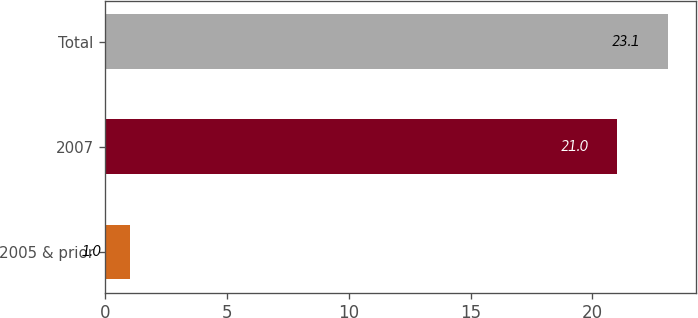Convert chart to OTSL. <chart><loc_0><loc_0><loc_500><loc_500><bar_chart><fcel>2005 & prior<fcel>2007<fcel>Total<nl><fcel>1<fcel>21<fcel>23.1<nl></chart> 